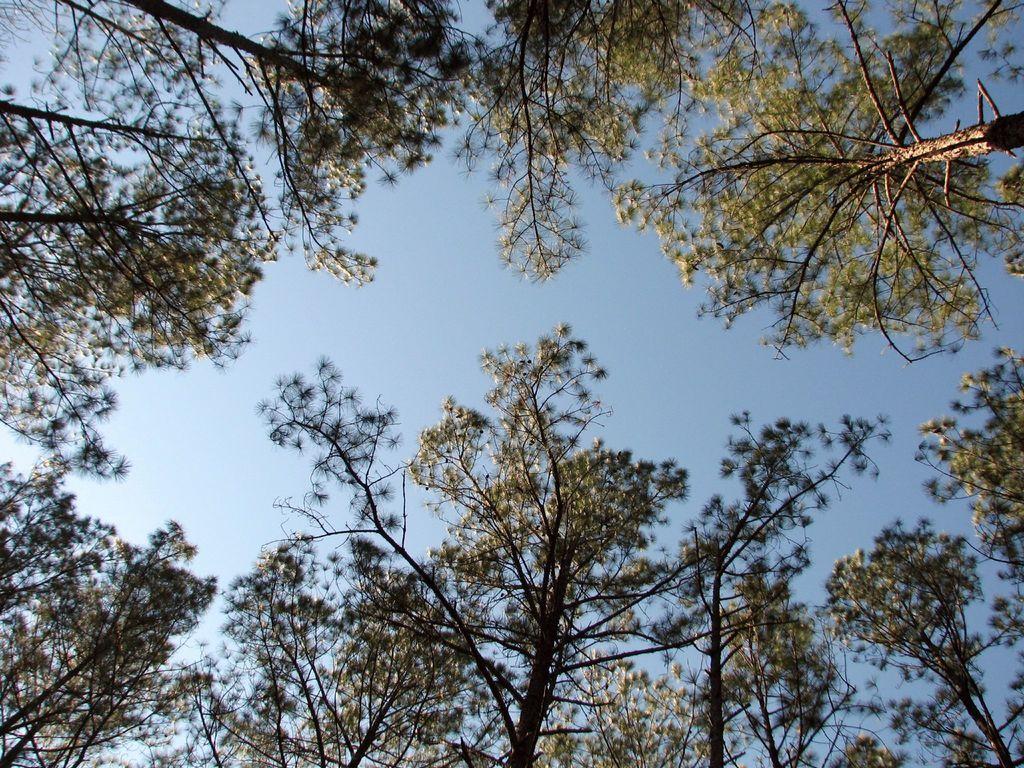Can you describe this image briefly? In this picture we so many trees and sky. 